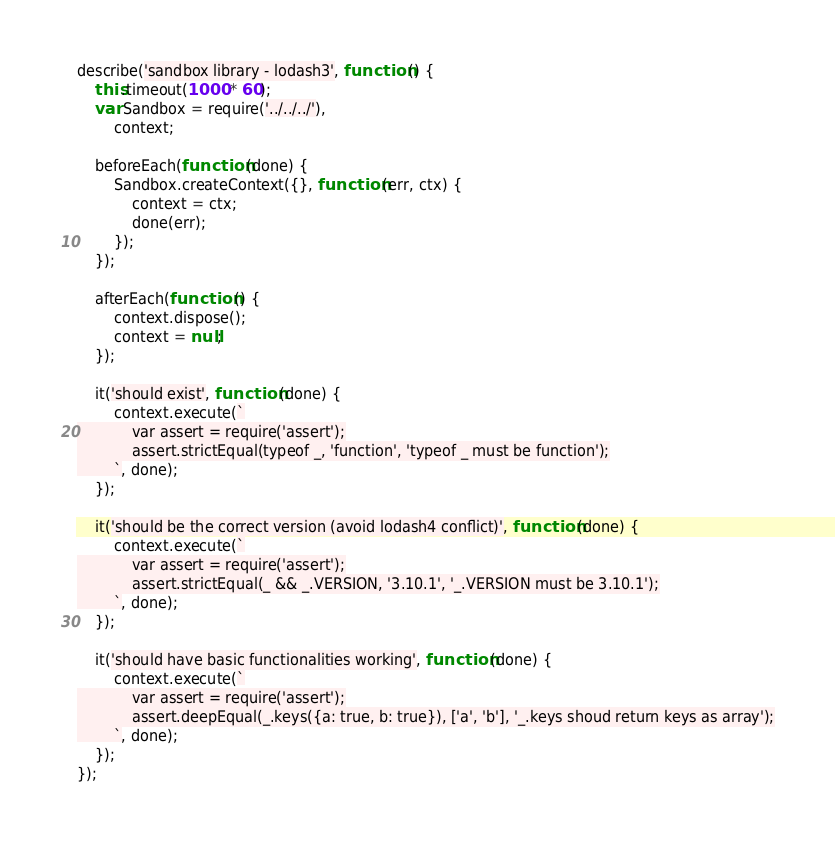<code> <loc_0><loc_0><loc_500><loc_500><_JavaScript_>describe('sandbox library - lodash3', function () {
    this.timeout(1000 * 60);
    var Sandbox = require('../../../'),
        context;

    beforeEach(function (done) {
        Sandbox.createContext({}, function (err, ctx) {
            context = ctx;
            done(err);
        });
    });

    afterEach(function () {
        context.dispose();
        context = null;
    });

    it('should exist', function (done) {
        context.execute(`
            var assert = require('assert');
            assert.strictEqual(typeof _, 'function', 'typeof _ must be function');
        `, done);
    });

    it('should be the correct version (avoid lodash4 conflict)', function (done) {
        context.execute(`
            var assert = require('assert');
            assert.strictEqual(_ && _.VERSION, '3.10.1', '_.VERSION must be 3.10.1');
        `, done);
    });

    it('should have basic functionalities working', function (done) {
        context.execute(`
            var assert = require('assert');
            assert.deepEqual(_.keys({a: true, b: true}), ['a', 'b'], '_.keys shoud return keys as array');
        `, done);
    });
});
</code> 